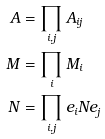<formula> <loc_0><loc_0><loc_500><loc_500>A & = \prod _ { i , j } A _ { i j } \\ M & = \prod _ { i } M _ { i } \\ N & = \prod _ { i , j } e _ { i } N e _ { j }</formula> 